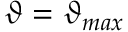<formula> <loc_0><loc_0><loc_500><loc_500>\vartheta = \vartheta _ { \max }</formula> 